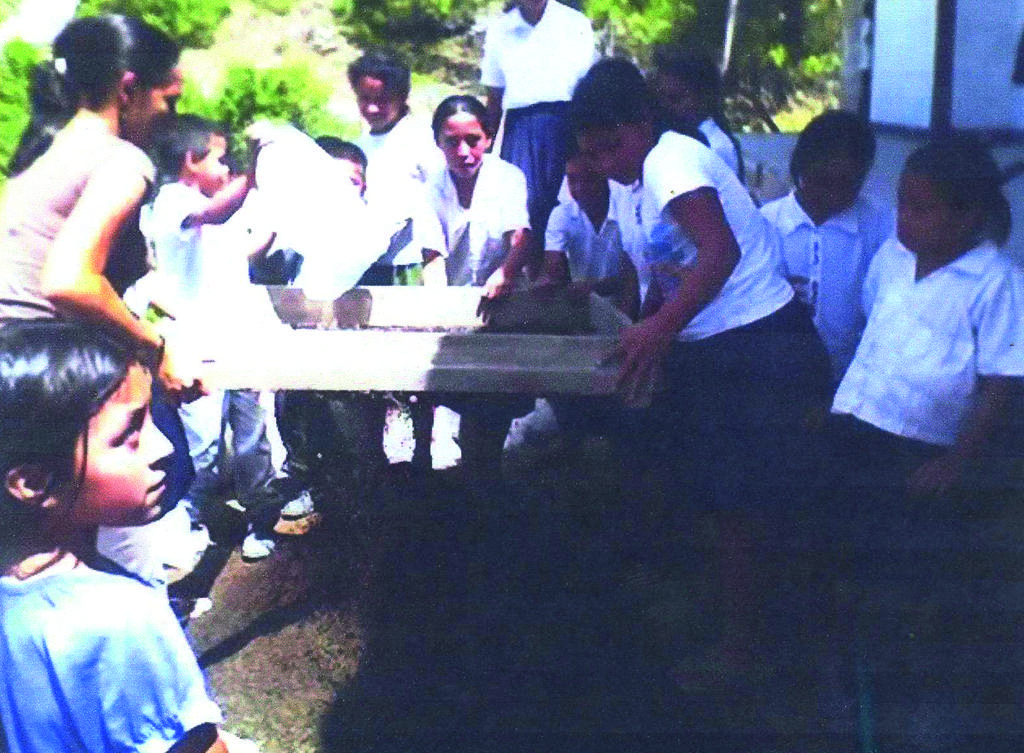In one or two sentences, can you explain what this image depicts? This picture is clicked outside. In the center we can see the group of people holding some objects and standing. On the right we can see the kids standing on the ground. In the background we can see the plants and a white color object. 